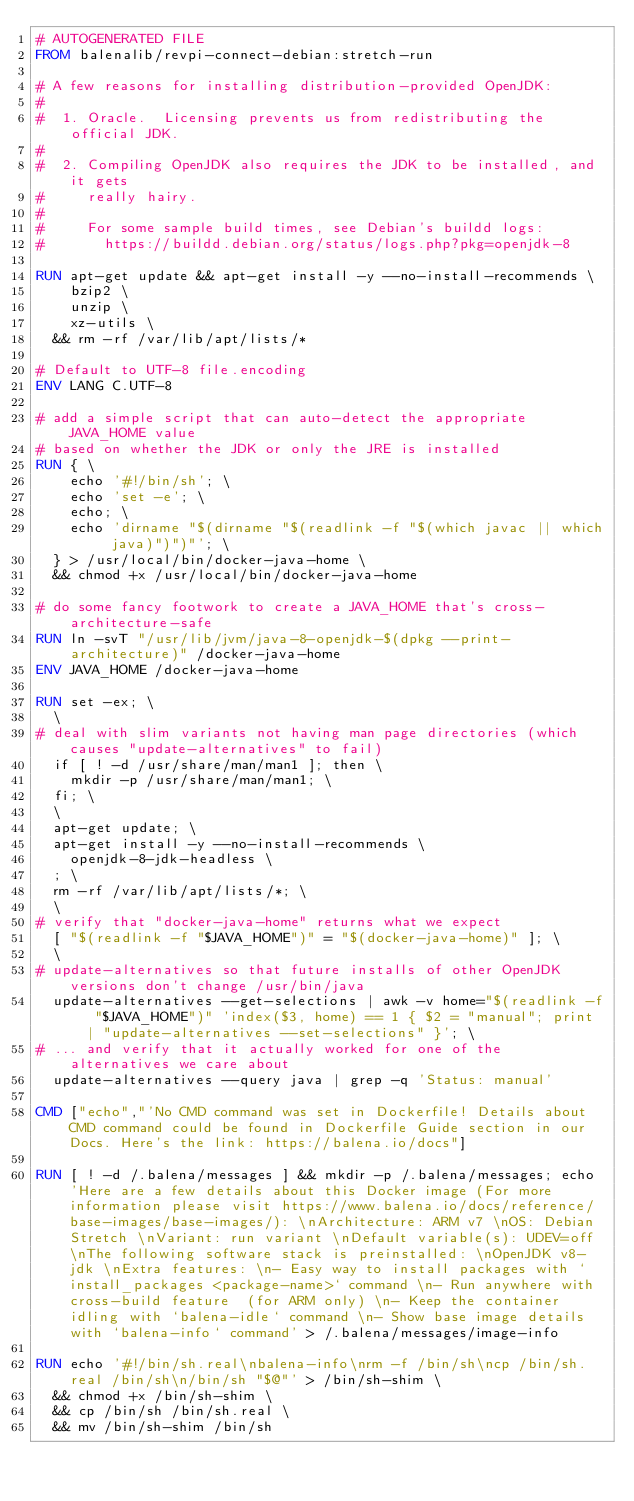<code> <loc_0><loc_0><loc_500><loc_500><_Dockerfile_># AUTOGENERATED FILE
FROM balenalib/revpi-connect-debian:stretch-run

# A few reasons for installing distribution-provided OpenJDK:
#
#  1. Oracle.  Licensing prevents us from redistributing the official JDK.
#
#  2. Compiling OpenJDK also requires the JDK to be installed, and it gets
#     really hairy.
#
#     For some sample build times, see Debian's buildd logs:
#       https://buildd.debian.org/status/logs.php?pkg=openjdk-8

RUN apt-get update && apt-get install -y --no-install-recommends \
		bzip2 \
		unzip \
		xz-utils \
	&& rm -rf /var/lib/apt/lists/*

# Default to UTF-8 file.encoding
ENV LANG C.UTF-8

# add a simple script that can auto-detect the appropriate JAVA_HOME value
# based on whether the JDK or only the JRE is installed
RUN { \
		echo '#!/bin/sh'; \
		echo 'set -e'; \
		echo; \
		echo 'dirname "$(dirname "$(readlink -f "$(which javac || which java)")")"'; \
	} > /usr/local/bin/docker-java-home \
	&& chmod +x /usr/local/bin/docker-java-home

# do some fancy footwork to create a JAVA_HOME that's cross-architecture-safe
RUN ln -svT "/usr/lib/jvm/java-8-openjdk-$(dpkg --print-architecture)" /docker-java-home
ENV JAVA_HOME /docker-java-home

RUN set -ex; \
	\
# deal with slim variants not having man page directories (which causes "update-alternatives" to fail)
	if [ ! -d /usr/share/man/man1 ]; then \
		mkdir -p /usr/share/man/man1; \
	fi; \
	\
	apt-get update; \
	apt-get install -y --no-install-recommends \
		openjdk-8-jdk-headless \
	; \
	rm -rf /var/lib/apt/lists/*; \
	\
# verify that "docker-java-home" returns what we expect
	[ "$(readlink -f "$JAVA_HOME")" = "$(docker-java-home)" ]; \
	\
# update-alternatives so that future installs of other OpenJDK versions don't change /usr/bin/java
	update-alternatives --get-selections | awk -v home="$(readlink -f "$JAVA_HOME")" 'index($3, home) == 1 { $2 = "manual"; print | "update-alternatives --set-selections" }'; \
# ... and verify that it actually worked for one of the alternatives we care about
	update-alternatives --query java | grep -q 'Status: manual'

CMD ["echo","'No CMD command was set in Dockerfile! Details about CMD command could be found in Dockerfile Guide section in our Docs. Here's the link: https://balena.io/docs"]

RUN [ ! -d /.balena/messages ] && mkdir -p /.balena/messages; echo 'Here are a few details about this Docker image (For more information please visit https://www.balena.io/docs/reference/base-images/base-images/): \nArchitecture: ARM v7 \nOS: Debian Stretch \nVariant: run variant \nDefault variable(s): UDEV=off \nThe following software stack is preinstalled: \nOpenJDK v8-jdk \nExtra features: \n- Easy way to install packages with `install_packages <package-name>` command \n- Run anywhere with cross-build feature  (for ARM only) \n- Keep the container idling with `balena-idle` command \n- Show base image details with `balena-info` command' > /.balena/messages/image-info

RUN echo '#!/bin/sh.real\nbalena-info\nrm -f /bin/sh\ncp /bin/sh.real /bin/sh\n/bin/sh "$@"' > /bin/sh-shim \
	&& chmod +x /bin/sh-shim \
	&& cp /bin/sh /bin/sh.real \
	&& mv /bin/sh-shim /bin/sh</code> 